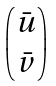Convert formula to latex. <formula><loc_0><loc_0><loc_500><loc_500>\begin{pmatrix} \bar { u } \\ \bar { v } \end{pmatrix}</formula> 